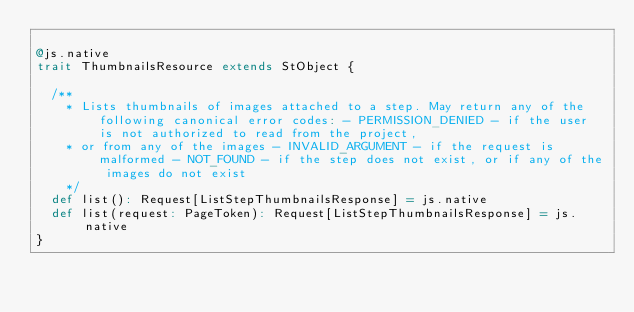<code> <loc_0><loc_0><loc_500><loc_500><_Scala_>
@js.native
trait ThumbnailsResource extends StObject {
  
  /**
    * Lists thumbnails of images attached to a step. May return any of the following canonical error codes: - PERMISSION_DENIED - if the user is not authorized to read from the project,
    * or from any of the images - INVALID_ARGUMENT - if the request is malformed - NOT_FOUND - if the step does not exist, or if any of the images do not exist
    */
  def list(): Request[ListStepThumbnailsResponse] = js.native
  def list(request: PageToken): Request[ListStepThumbnailsResponse] = js.native
}
</code> 